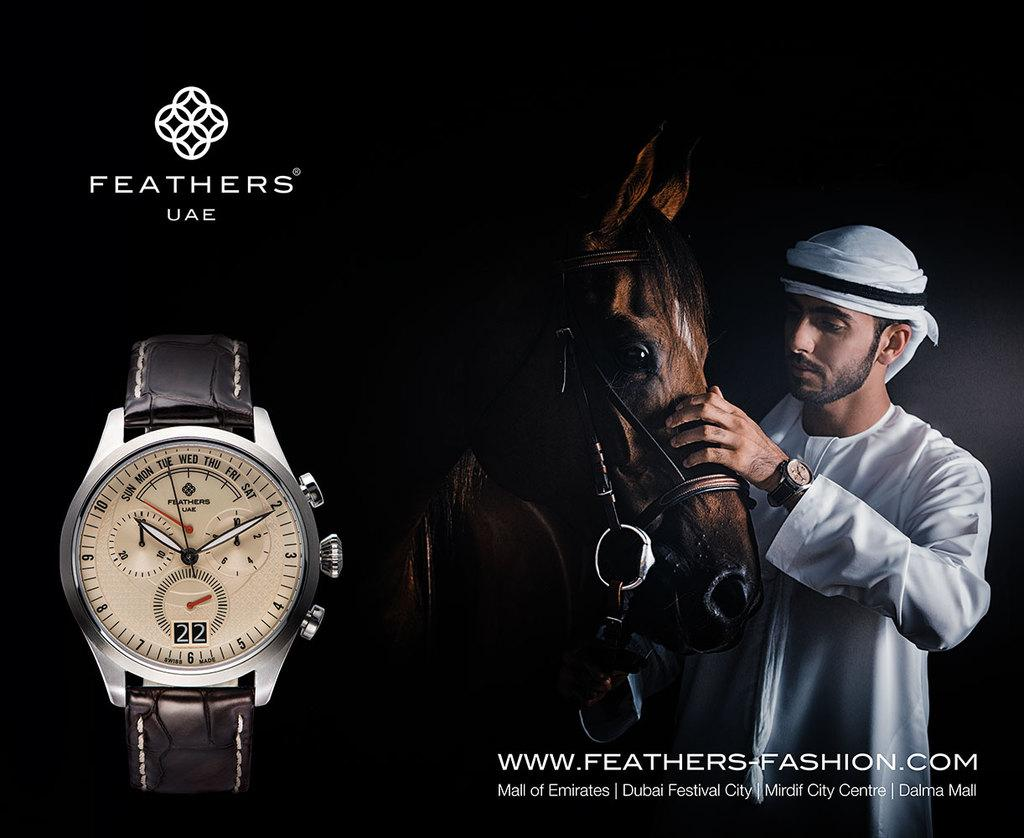<image>
Summarize the visual content of the image. An advertisement for FEATHERS' UAE watch has one with the time at 10:10. 